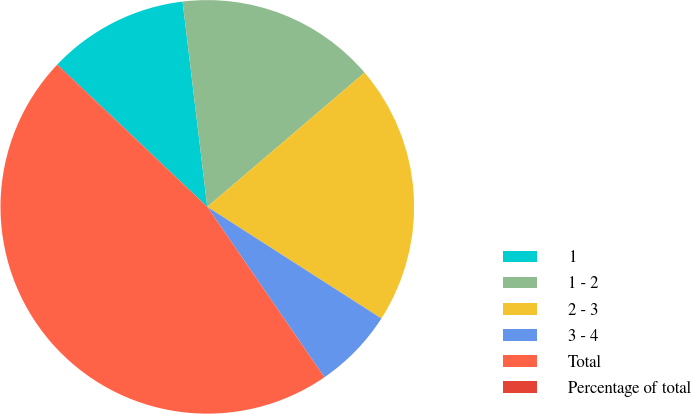Convert chart to OTSL. <chart><loc_0><loc_0><loc_500><loc_500><pie_chart><fcel>1<fcel>1 - 2<fcel>2 - 3<fcel>3 - 4<fcel>Total<fcel>Percentage of total<nl><fcel>11.0%<fcel>15.66%<fcel>20.32%<fcel>6.34%<fcel>46.63%<fcel>0.05%<nl></chart> 